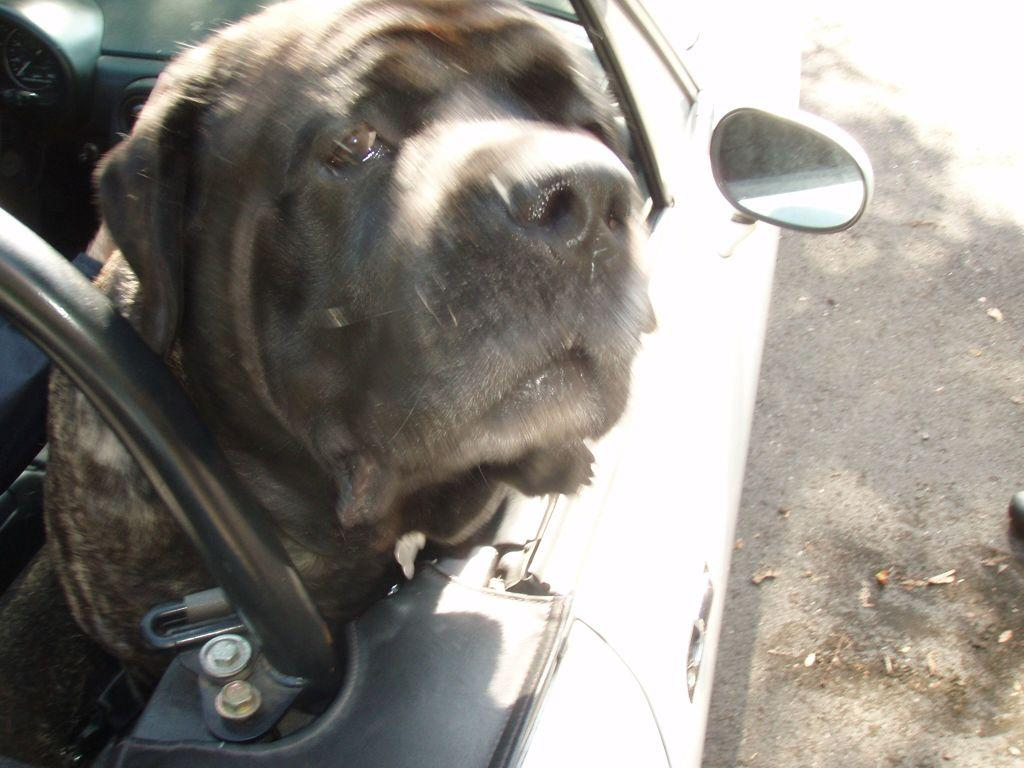What type of animal is in the image? There is a black dog in the image. Where is the dog located? The dog is looking out of a car. What object related to the car can be seen in the image? There is a mirror for the car in the image. What type of bottle is the dog holding in the image? There is no bottle present in the image; the dog is looking out of a car. 